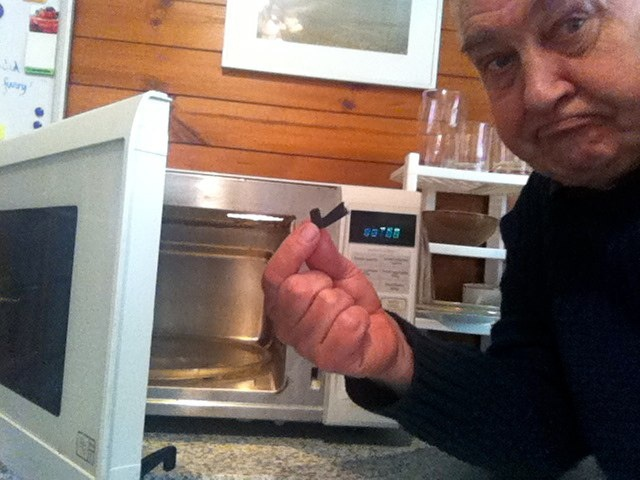Describe the objects in this image and their specific colors. I can see microwave in white, darkgray, lightgray, gray, and black tones, people in white, black, brown, maroon, and salmon tones, cup in lavender, gray, salmon, darkgray, and lightpink tones, bowl in lavender, maroon, black, and gray tones, and cup in white and gray tones in this image. 